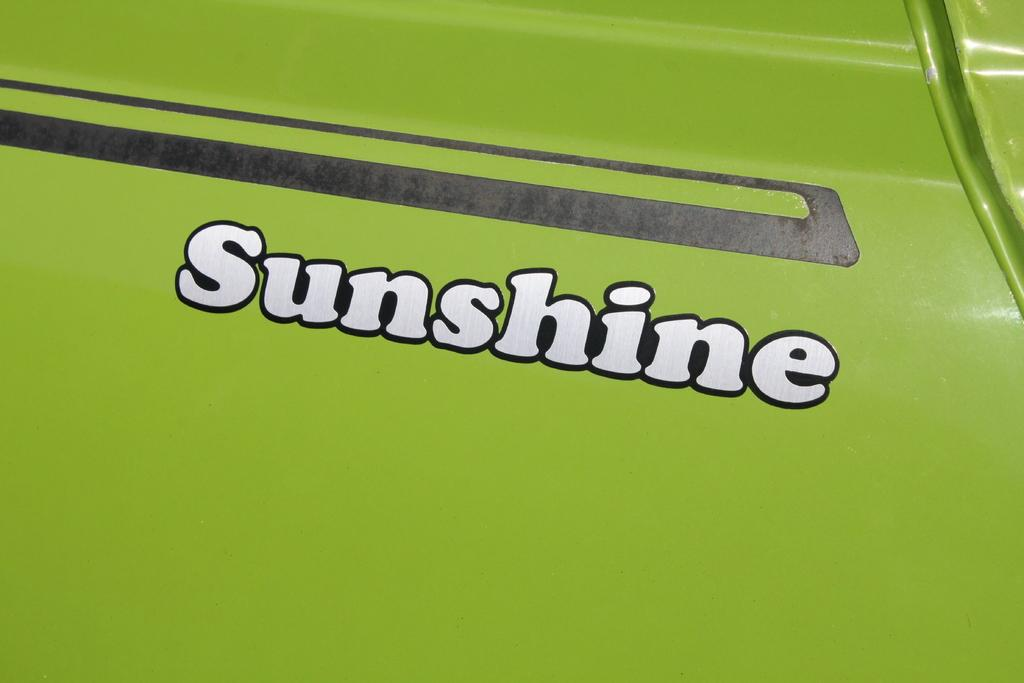What is the main subject of the image? There is a vehicle in the image. Can you describe the color of the vehicle? The vehicle is green in color. Is there a crib filled with oranges in the image? No, there is no crib or oranges present in the image. 